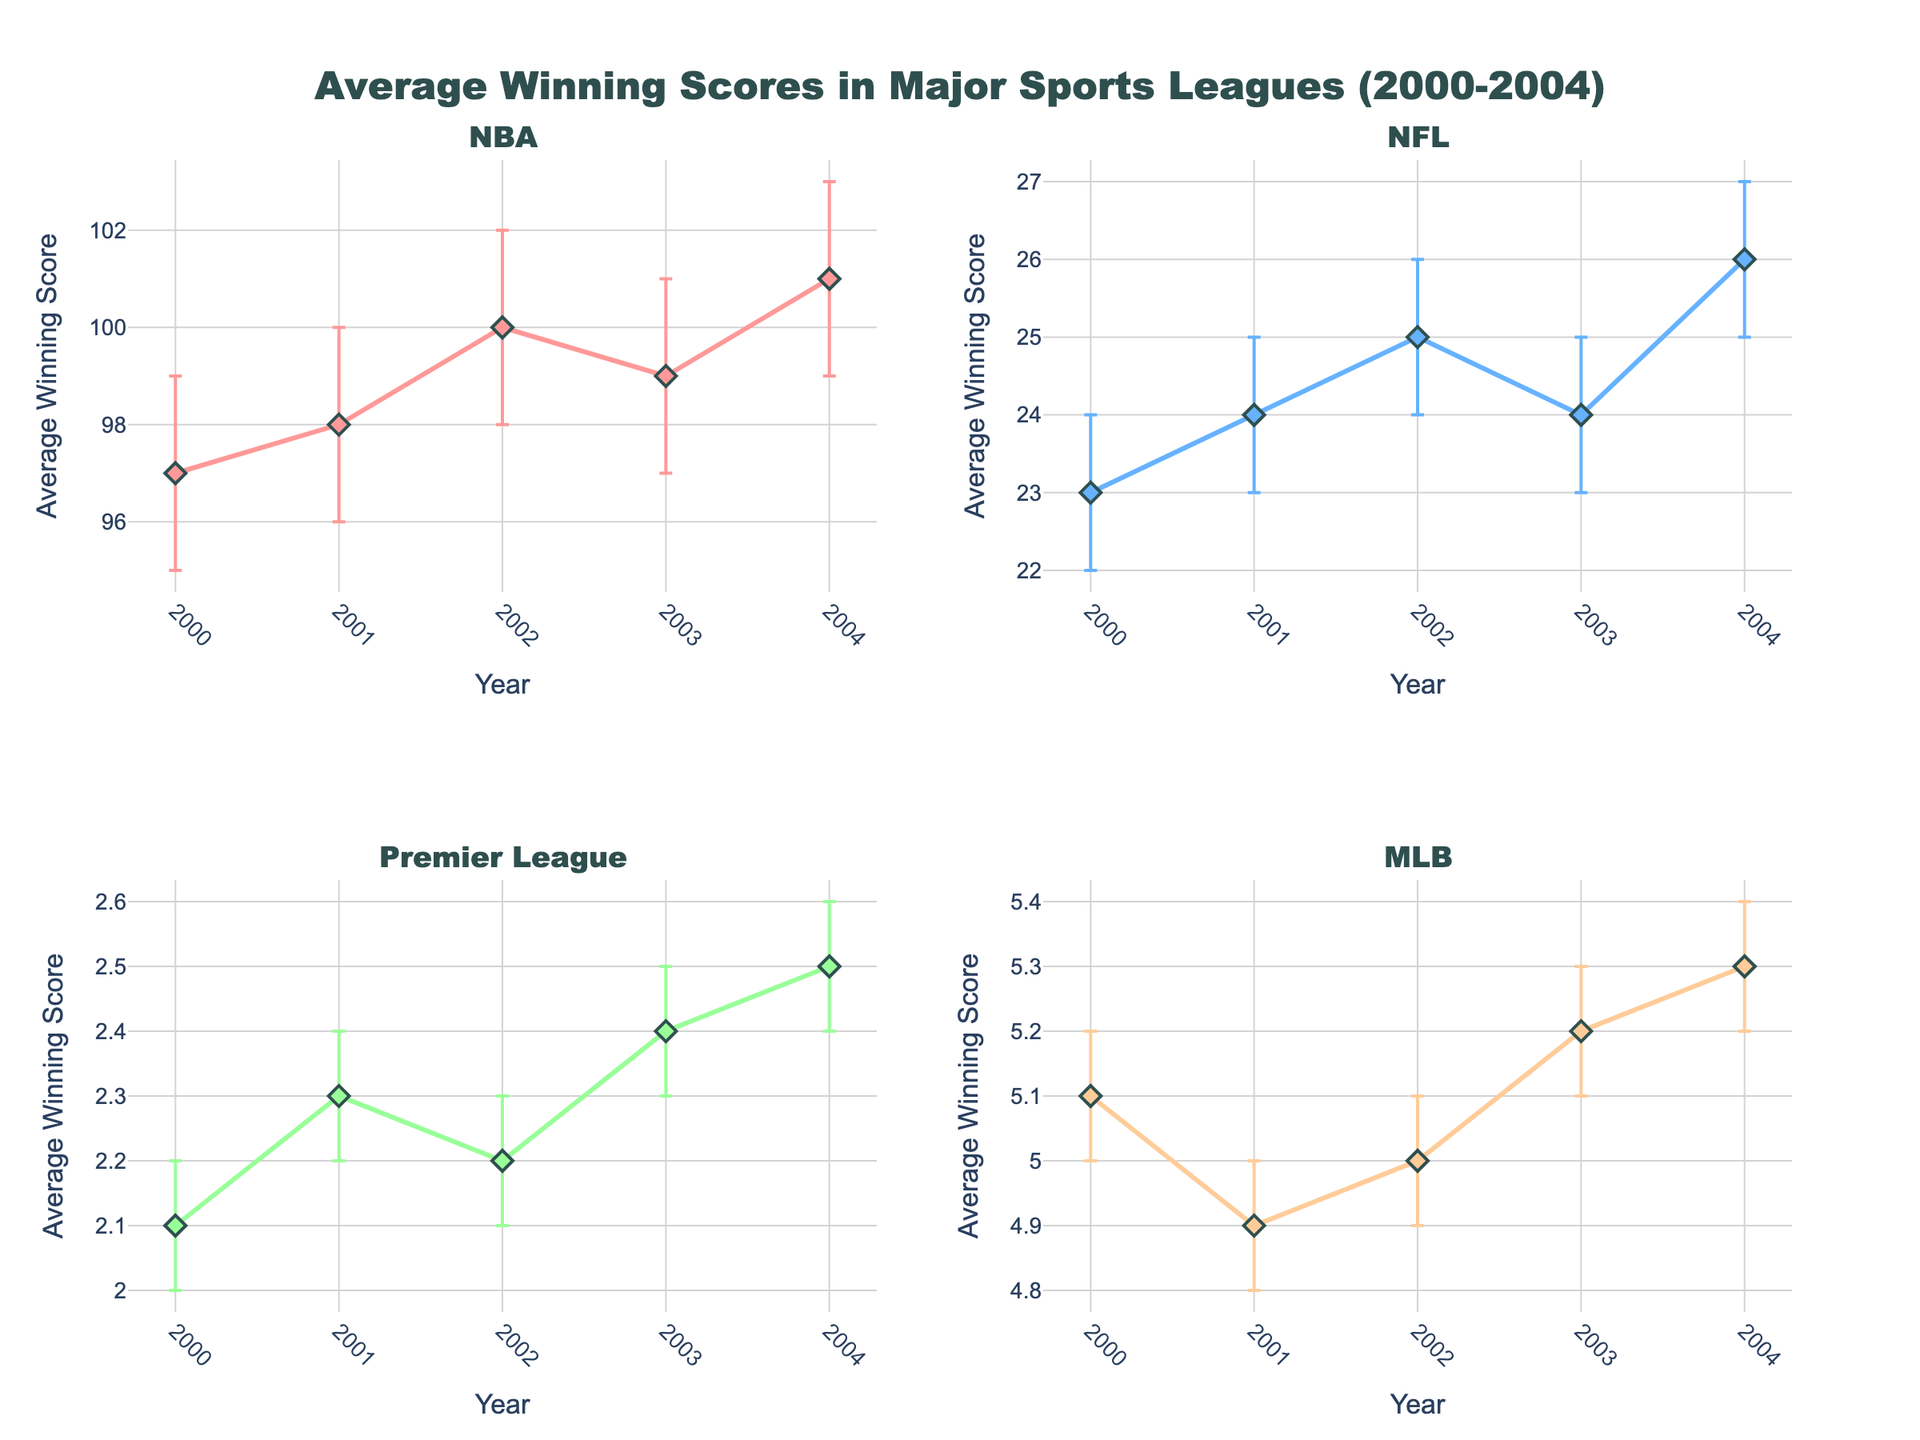What is the title of the figure? The title is visible at the top of the figure.
Answer: Average Winning Scores in Major Sports Leagues (2000-2004) How many subplots are there in the figure? The figure shows four subplots, arranged in a 2x2 grid.
Answer: 4 Which sport has the lowest average winning score in 2002? In 2002, comparing the average winning scores across all sports, Soccer (Premier League) has the lowest with a score of 2.2.
Answer: Soccer (Premier League) In which year does the NBA have the highest average winning score, and what is that score? The NBA's highest average winning score appears in 2004 with a score of 101.
Answer: 2004, 101 What is the confidence interval for MLB in 2001? The confidence interval can be read directly from the error bars of the MLB plot for 2001, from 4.8 to 5.0.
Answer: 4.8 to 5.0 Which league shows the greatest increase in average winning score from 2000 to 2004? By comparing the changes in average winning scores from 2000 to 2004 across leagues, Football (NFL) increases from 23 to 26, a rise of 3 points, the highest among the leagues.
Answer: Football (NFL) Compare the average winning scores for the NFL in 2002 and 2003. Which year had a higher average winning score, and by how much? The NFL had an average winning score of 25 in 2002 and 24 in 2003, showing a decrease of 1 point from 2002 to 2003.
Answer: 2002, by 1 point What trend can you observe in the average winning scores of the Premier League from 2000 to 2004? The Premier League winning scores increased overall from 2.1 in 2000 to 2.5 in 2004.
Answer: Increasing trend Which sport's confidence intervals overlap the most over the years, indicating consistency? Soccer's (Premier League) confidence intervals have the most overlap, indicating consistent average winning scores over the years.
Answer: Soccer (Premier League) What is the range of average winning scores for Basketball (NBA) from 2000 to 2004? The average winning scores for Basketball (NBA) range from a low of 97 in 2000 to a high of 101 in 2004.
Answer: 97 to 101 